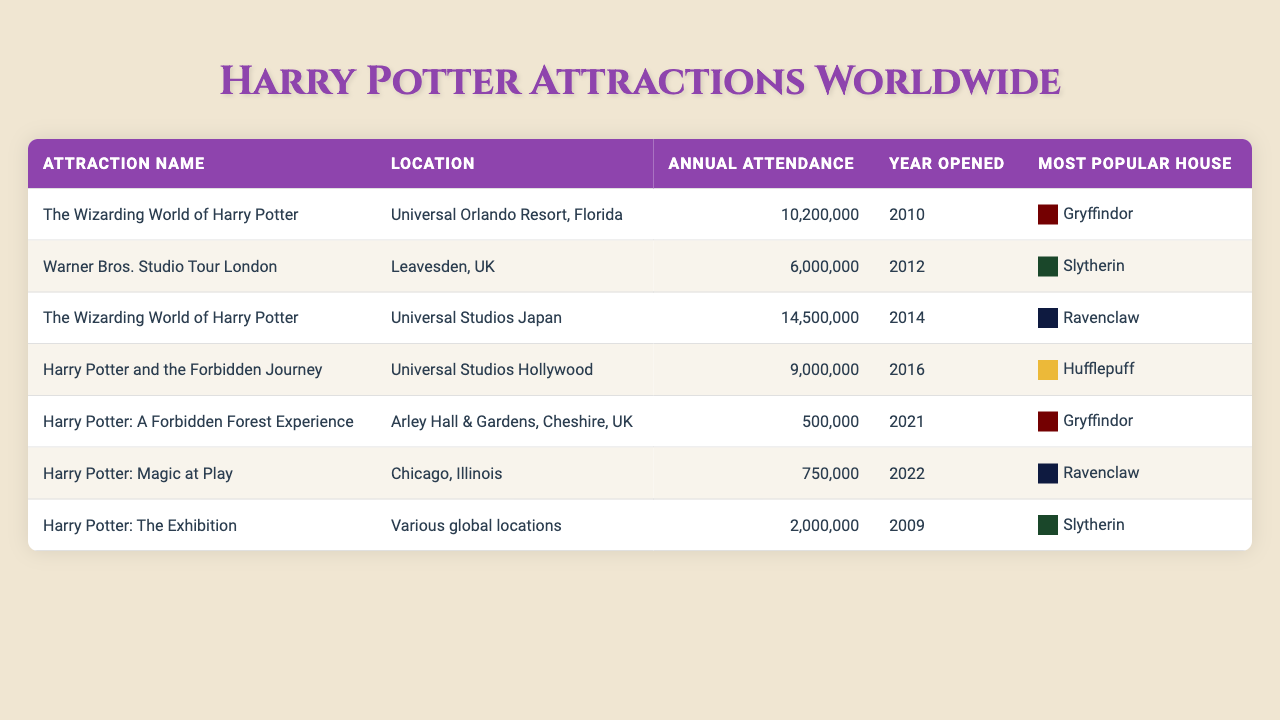What is the annual attendance for The Wizarding World of Harry Potter at Universal Orlando Resort? The attendance for The Wizarding World of Harry Potter at Universal Orlando Resort is listed as 10,200,000 in the table.
Answer: 10,200,000 Which attraction has the highest annual attendance? By reviewing the attendance figures in the table, The Wizarding World of Harry Potter at Universal Studios Japan has the highest annual attendance at 14,500,000.
Answer: The Wizarding World of Harry Potter (Universal Studios Japan) In what year did Harry Potter: A Forbidden Forest Experience open? The table indicates that Harry Potter: A Forbidden Forest Experience opened in 2021.
Answer: 2021 How many attractions have Gryffindor as the most popular house? The table lists two attractions associated with Gryffindor: The Wizarding World of Harry Potter in Universal Orlando Resort and Harry Potter: A Forbidden Forest Experience.
Answer: 2 What is the total annual attendance of all the attractions listed? First, we sum the annual attendances: 10,200,000 + 6,000,000 + 14,500,000 + 9,000,000 + 500,000 + 750,000 + 2,000,000 = 42,950,000.
Answer: 42,950,000 Is the most popular house for Harry Potter: Magic at Play Ravenclaw? According to the table, the most popular house for Harry Potter: Magic at Play is indeed Ravenclaw.
Answer: Yes How does the attendance for Warner Bros. Studio Tour London compare to that of Harry Potter and the Forbidden Journey? Warner Bros. Studio Tour London has an attendance of 6,000,000, while Harry Potter and the Forbidden Journey has an attendance of 9,000,000, making Harry Potter and the Forbidden Journey more popular by 3,000,000 attendees.
Answer: It has 3,000,000 fewer attendees What is the average annual attendance for the attractions featuring Gryffindor? The annual attendance for Gryffindor attractions are 10,200,000 (Universal Orlando Resort) and 500,000 (Harry Potter: A Forbidden Forest Experience). The average is (10,200,000 + 500,000) / 2 = 5,350,000.
Answer: 5,350,000 Which attraction opened most recently and what is its annual attendance? From the table, Harry Potter: Magic at Play opened in 2022 and it has an annual attendance of 750,000.
Answer: Harry Potter: Magic at Play; 750,000 Is it true that The Wizarding World of Harry Potter at Universal Orlando Resort opened earlier than Harry Potter: The Exhibition? The table shows The Wizarding World of Harry Potter opened in 2010 and Harry Potter: The Exhibition opened in 2009, making this statement false.
Answer: No 